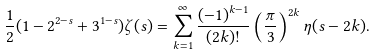<formula> <loc_0><loc_0><loc_500><loc_500>\frac { 1 } { 2 } ( 1 - 2 ^ { 2 - s } + 3 ^ { 1 - s } ) \zeta ( s ) = \sum ^ { \infty } _ { k = 1 } \frac { ( - 1 ) ^ { k - 1 } } { ( 2 k ) ! } \left ( \frac { \pi } { 3 } \right ) ^ { 2 k } \eta ( s - 2 k ) .</formula> 